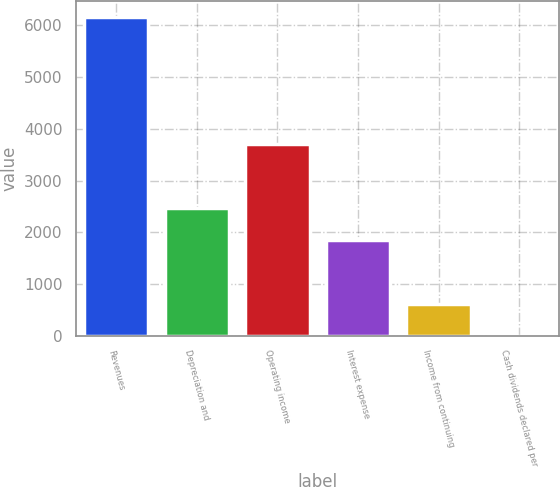<chart> <loc_0><loc_0><loc_500><loc_500><bar_chart><fcel>Revenues<fcel>Depreciation and<fcel>Operating income<fcel>Interest expense<fcel>Income from continuing<fcel>Cash dividends declared per<nl><fcel>6172<fcel>2469.45<fcel>3703.63<fcel>1852.36<fcel>618.18<fcel>1.09<nl></chart> 